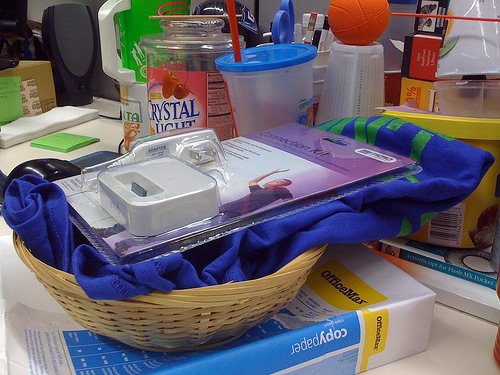<image>
Is there a paper under the basket? Yes. The paper is positioned underneath the basket, with the basket above it in the vertical space. Where is the basket in relation to the paper? Is it on the paper? Yes. Looking at the image, I can see the basket is positioned on top of the paper, with the paper providing support. 